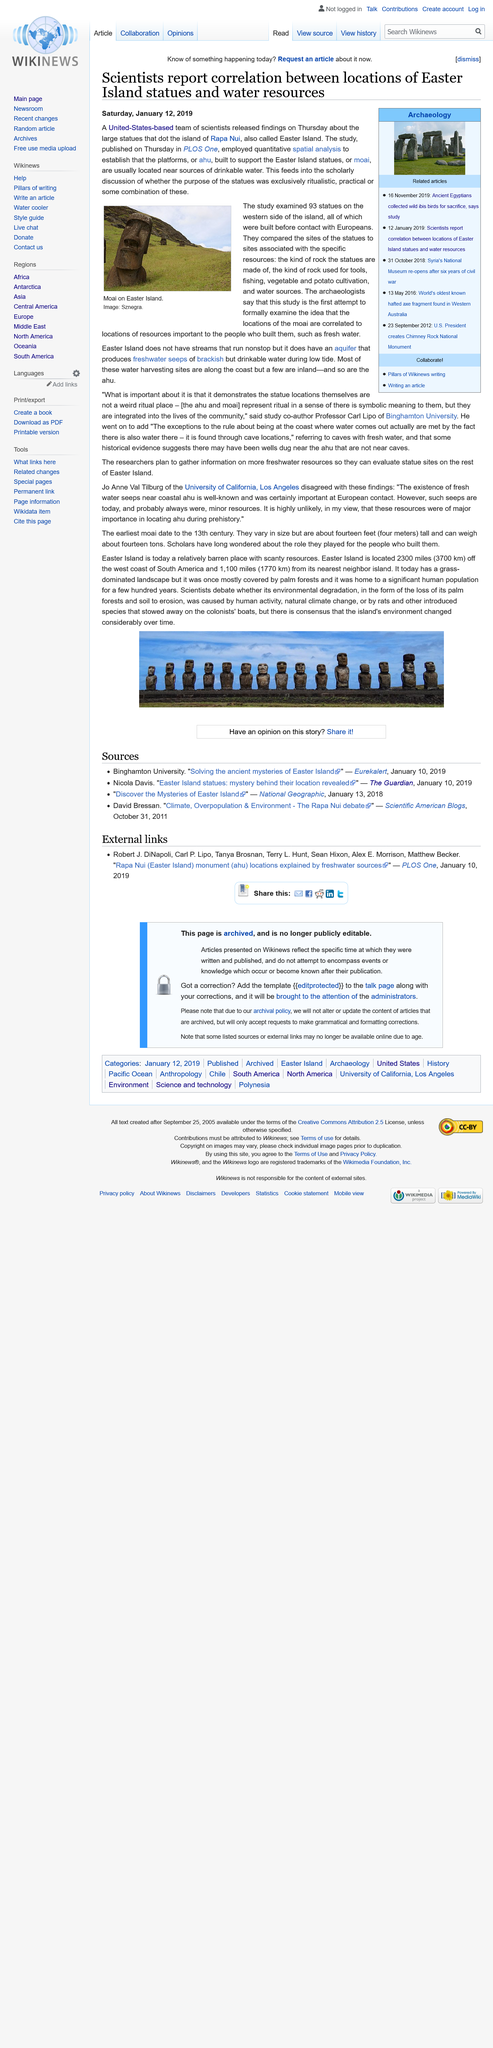List a handful of essential elements in this visual. The study was published in PLOS One, a well-respected scientific journal. Easter Island, which is located 2300 miles off the west coast of South America, is a Polynesian island that is famous for its monumental statues, known as Moai, which are believed to have been created by the island's ancient population. Jo Anne Val Tilburg of the University of California, Los Angeles, disagreed with the findings that the Ahu and Moai were location markers for fresh water. The earliest moai date back to the 13th century. The picture depicts a Moai on Easter Island, which is a famous landmark in the Polynesian islands. 